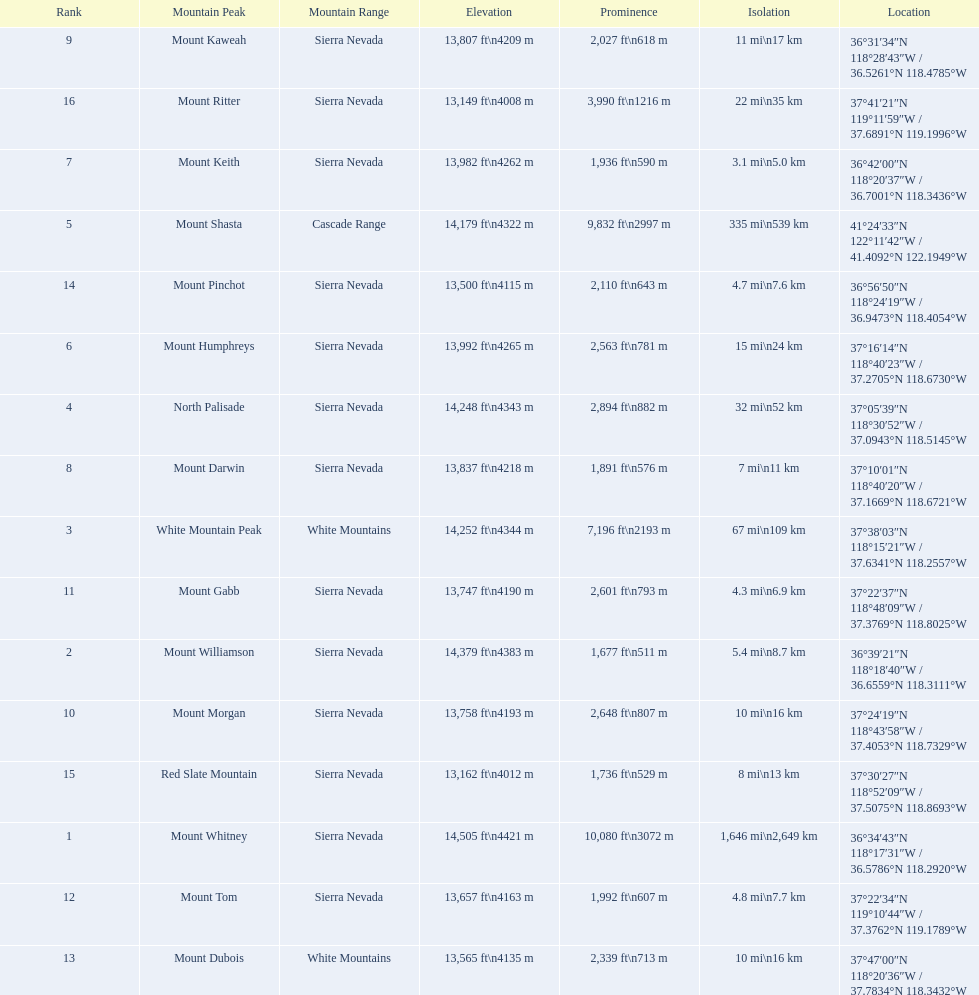What are the heights of the peaks? 14,505 ft\n4421 m, 14,379 ft\n4383 m, 14,252 ft\n4344 m, 14,248 ft\n4343 m, 14,179 ft\n4322 m, 13,992 ft\n4265 m, 13,982 ft\n4262 m, 13,837 ft\n4218 m, 13,807 ft\n4209 m, 13,758 ft\n4193 m, 13,747 ft\n4190 m, 13,657 ft\n4163 m, 13,565 ft\n4135 m, 13,500 ft\n4115 m, 13,162 ft\n4012 m, 13,149 ft\n4008 m. Which of these heights is tallest? 14,505 ft\n4421 m. What peak is 14,505 feet? Mount Whitney. 